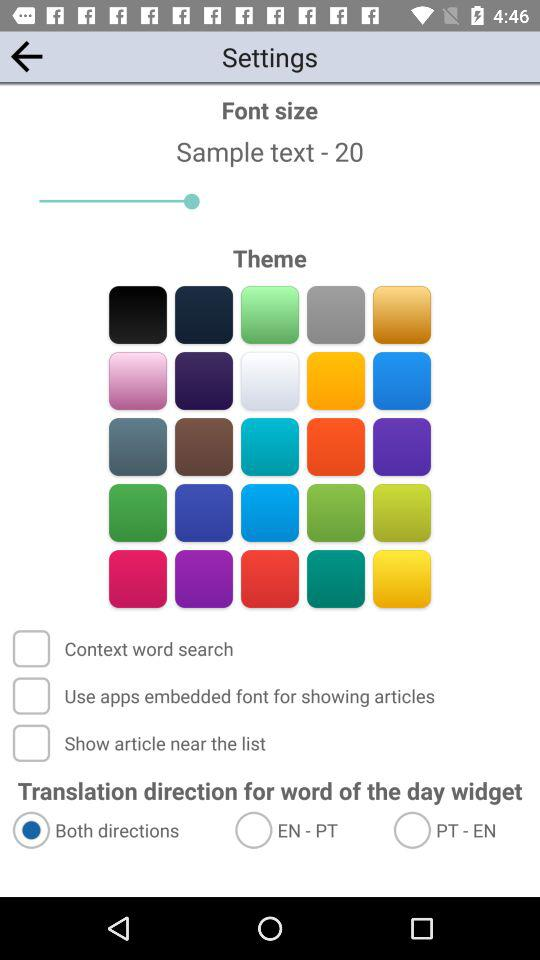What is the font size? The font size is 20. 